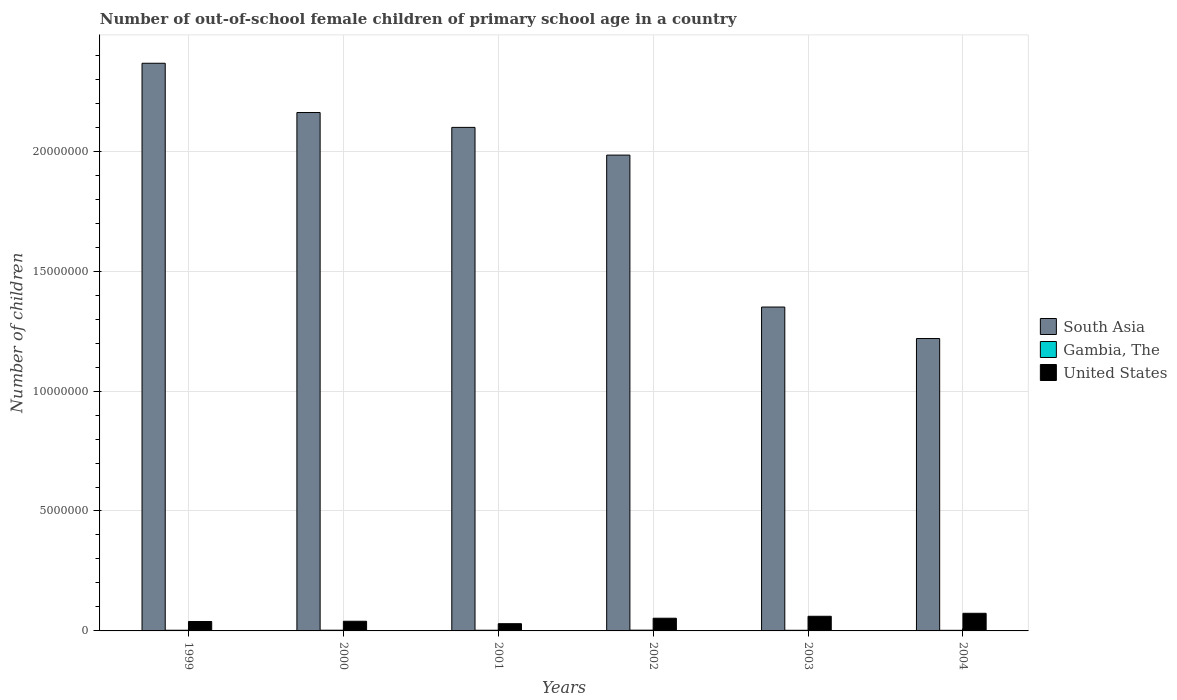How many groups of bars are there?
Make the answer very short. 6. Are the number of bars per tick equal to the number of legend labels?
Provide a succinct answer. Yes. Are the number of bars on each tick of the X-axis equal?
Your response must be concise. Yes. How many bars are there on the 6th tick from the left?
Your answer should be compact. 3. What is the label of the 5th group of bars from the left?
Your answer should be very brief. 2003. What is the number of out-of-school female children in South Asia in 2002?
Keep it short and to the point. 1.98e+07. Across all years, what is the maximum number of out-of-school female children in United States?
Your response must be concise. 7.35e+05. Across all years, what is the minimum number of out-of-school female children in United States?
Provide a short and direct response. 3.01e+05. In which year was the number of out-of-school female children in South Asia maximum?
Offer a very short reply. 1999. In which year was the number of out-of-school female children in United States minimum?
Make the answer very short. 2001. What is the total number of out-of-school female children in United States in the graph?
Make the answer very short. 2.97e+06. What is the difference between the number of out-of-school female children in Gambia, The in 2000 and that in 2004?
Provide a short and direct response. 4613. What is the difference between the number of out-of-school female children in South Asia in 2003 and the number of out-of-school female children in United States in 2001?
Your answer should be very brief. 1.32e+07. What is the average number of out-of-school female children in Gambia, The per year?
Offer a terse response. 2.82e+04. In the year 2003, what is the difference between the number of out-of-school female children in Gambia, The and number of out-of-school female children in South Asia?
Offer a very short reply. -1.35e+07. What is the ratio of the number of out-of-school female children in South Asia in 2001 to that in 2002?
Your answer should be compact. 1.06. Is the difference between the number of out-of-school female children in Gambia, The in 2001 and 2004 greater than the difference between the number of out-of-school female children in South Asia in 2001 and 2004?
Ensure brevity in your answer.  No. What is the difference between the highest and the second highest number of out-of-school female children in Gambia, The?
Your answer should be very brief. 1330. What is the difference between the highest and the lowest number of out-of-school female children in Gambia, The?
Provide a succinct answer. 5943. In how many years, is the number of out-of-school female children in United States greater than the average number of out-of-school female children in United States taken over all years?
Your answer should be very brief. 3. Is the sum of the number of out-of-school female children in South Asia in 2002 and 2004 greater than the maximum number of out-of-school female children in Gambia, The across all years?
Offer a terse response. Yes. What does the 2nd bar from the left in 2002 represents?
Keep it short and to the point. Gambia, The. What does the 2nd bar from the right in 2003 represents?
Provide a short and direct response. Gambia, The. Are all the bars in the graph horizontal?
Make the answer very short. No. How many years are there in the graph?
Ensure brevity in your answer.  6. Does the graph contain any zero values?
Provide a succinct answer. No. Does the graph contain grids?
Give a very brief answer. Yes. Where does the legend appear in the graph?
Your answer should be very brief. Center right. How are the legend labels stacked?
Provide a short and direct response. Vertical. What is the title of the graph?
Offer a very short reply. Number of out-of-school female children of primary school age in a country. What is the label or title of the X-axis?
Make the answer very short. Years. What is the label or title of the Y-axis?
Your answer should be very brief. Number of children. What is the Number of children in South Asia in 1999?
Provide a short and direct response. 2.37e+07. What is the Number of children of Gambia, The in 1999?
Give a very brief answer. 2.84e+04. What is the Number of children of United States in 1999?
Make the answer very short. 3.93e+05. What is the Number of children of South Asia in 2000?
Ensure brevity in your answer.  2.16e+07. What is the Number of children in Gambia, The in 2000?
Your response must be concise. 2.99e+04. What is the Number of children of United States in 2000?
Keep it short and to the point. 4.03e+05. What is the Number of children of South Asia in 2001?
Make the answer very short. 2.10e+07. What is the Number of children of Gambia, The in 2001?
Make the answer very short. 2.83e+04. What is the Number of children in United States in 2001?
Make the answer very short. 3.01e+05. What is the Number of children in South Asia in 2002?
Make the answer very short. 1.98e+07. What is the Number of children of Gambia, The in 2002?
Ensure brevity in your answer.  3.12e+04. What is the Number of children in United States in 2002?
Provide a succinct answer. 5.29e+05. What is the Number of children in South Asia in 2003?
Offer a very short reply. 1.35e+07. What is the Number of children in Gambia, The in 2003?
Offer a terse response. 2.61e+04. What is the Number of children of United States in 2003?
Offer a very short reply. 6.11e+05. What is the Number of children in South Asia in 2004?
Offer a very short reply. 1.22e+07. What is the Number of children in Gambia, The in 2004?
Offer a very short reply. 2.53e+04. What is the Number of children of United States in 2004?
Your response must be concise. 7.35e+05. Across all years, what is the maximum Number of children in South Asia?
Offer a terse response. 2.37e+07. Across all years, what is the maximum Number of children in Gambia, The?
Your answer should be very brief. 3.12e+04. Across all years, what is the maximum Number of children of United States?
Provide a short and direct response. 7.35e+05. Across all years, what is the minimum Number of children of South Asia?
Offer a terse response. 1.22e+07. Across all years, what is the minimum Number of children in Gambia, The?
Make the answer very short. 2.53e+04. Across all years, what is the minimum Number of children in United States?
Provide a succinct answer. 3.01e+05. What is the total Number of children of South Asia in the graph?
Give a very brief answer. 1.12e+08. What is the total Number of children in Gambia, The in the graph?
Offer a terse response. 1.69e+05. What is the total Number of children in United States in the graph?
Your answer should be compact. 2.97e+06. What is the difference between the Number of children in South Asia in 1999 and that in 2000?
Ensure brevity in your answer.  2.05e+06. What is the difference between the Number of children of Gambia, The in 1999 and that in 2000?
Provide a succinct answer. -1558. What is the difference between the Number of children of United States in 1999 and that in 2000?
Provide a succinct answer. -1.00e+04. What is the difference between the Number of children of South Asia in 1999 and that in 2001?
Your response must be concise. 2.67e+06. What is the difference between the Number of children in United States in 1999 and that in 2001?
Ensure brevity in your answer.  9.15e+04. What is the difference between the Number of children of South Asia in 1999 and that in 2002?
Ensure brevity in your answer.  3.83e+06. What is the difference between the Number of children in Gambia, The in 1999 and that in 2002?
Offer a terse response. -2888. What is the difference between the Number of children of United States in 1999 and that in 2002?
Give a very brief answer. -1.36e+05. What is the difference between the Number of children in South Asia in 1999 and that in 2003?
Your answer should be very brief. 1.02e+07. What is the difference between the Number of children of Gambia, The in 1999 and that in 2003?
Your answer should be very brief. 2246. What is the difference between the Number of children in United States in 1999 and that in 2003?
Your response must be concise. -2.18e+05. What is the difference between the Number of children in South Asia in 1999 and that in 2004?
Make the answer very short. 1.15e+07. What is the difference between the Number of children of Gambia, The in 1999 and that in 2004?
Give a very brief answer. 3055. What is the difference between the Number of children of United States in 1999 and that in 2004?
Your answer should be compact. -3.42e+05. What is the difference between the Number of children of South Asia in 2000 and that in 2001?
Keep it short and to the point. 6.19e+05. What is the difference between the Number of children in Gambia, The in 2000 and that in 2001?
Your answer should be compact. 1583. What is the difference between the Number of children in United States in 2000 and that in 2001?
Make the answer very short. 1.01e+05. What is the difference between the Number of children of South Asia in 2000 and that in 2002?
Ensure brevity in your answer.  1.78e+06. What is the difference between the Number of children in Gambia, The in 2000 and that in 2002?
Offer a terse response. -1330. What is the difference between the Number of children in United States in 2000 and that in 2002?
Provide a succinct answer. -1.26e+05. What is the difference between the Number of children of South Asia in 2000 and that in 2003?
Your answer should be compact. 8.11e+06. What is the difference between the Number of children of Gambia, The in 2000 and that in 2003?
Provide a succinct answer. 3804. What is the difference between the Number of children in United States in 2000 and that in 2003?
Provide a succinct answer. -2.08e+05. What is the difference between the Number of children in South Asia in 2000 and that in 2004?
Your response must be concise. 9.42e+06. What is the difference between the Number of children of Gambia, The in 2000 and that in 2004?
Offer a very short reply. 4613. What is the difference between the Number of children of United States in 2000 and that in 2004?
Offer a very short reply. -3.32e+05. What is the difference between the Number of children in South Asia in 2001 and that in 2002?
Your answer should be compact. 1.16e+06. What is the difference between the Number of children in Gambia, The in 2001 and that in 2002?
Provide a short and direct response. -2913. What is the difference between the Number of children of United States in 2001 and that in 2002?
Provide a short and direct response. -2.28e+05. What is the difference between the Number of children in South Asia in 2001 and that in 2003?
Your response must be concise. 7.49e+06. What is the difference between the Number of children of Gambia, The in 2001 and that in 2003?
Offer a very short reply. 2221. What is the difference between the Number of children of United States in 2001 and that in 2003?
Give a very brief answer. -3.09e+05. What is the difference between the Number of children in South Asia in 2001 and that in 2004?
Your answer should be very brief. 8.80e+06. What is the difference between the Number of children in Gambia, The in 2001 and that in 2004?
Your answer should be very brief. 3030. What is the difference between the Number of children in United States in 2001 and that in 2004?
Ensure brevity in your answer.  -4.34e+05. What is the difference between the Number of children of South Asia in 2002 and that in 2003?
Offer a very short reply. 6.33e+06. What is the difference between the Number of children of Gambia, The in 2002 and that in 2003?
Ensure brevity in your answer.  5134. What is the difference between the Number of children of United States in 2002 and that in 2003?
Give a very brief answer. -8.13e+04. What is the difference between the Number of children of South Asia in 2002 and that in 2004?
Ensure brevity in your answer.  7.65e+06. What is the difference between the Number of children of Gambia, The in 2002 and that in 2004?
Your response must be concise. 5943. What is the difference between the Number of children of United States in 2002 and that in 2004?
Your response must be concise. -2.06e+05. What is the difference between the Number of children in South Asia in 2003 and that in 2004?
Provide a succinct answer. 1.31e+06. What is the difference between the Number of children of Gambia, The in 2003 and that in 2004?
Offer a very short reply. 809. What is the difference between the Number of children in United States in 2003 and that in 2004?
Offer a very short reply. -1.24e+05. What is the difference between the Number of children of South Asia in 1999 and the Number of children of Gambia, The in 2000?
Offer a very short reply. 2.36e+07. What is the difference between the Number of children of South Asia in 1999 and the Number of children of United States in 2000?
Keep it short and to the point. 2.33e+07. What is the difference between the Number of children of Gambia, The in 1999 and the Number of children of United States in 2000?
Offer a terse response. -3.74e+05. What is the difference between the Number of children in South Asia in 1999 and the Number of children in Gambia, The in 2001?
Your response must be concise. 2.36e+07. What is the difference between the Number of children of South Asia in 1999 and the Number of children of United States in 2001?
Give a very brief answer. 2.34e+07. What is the difference between the Number of children in Gambia, The in 1999 and the Number of children in United States in 2001?
Make the answer very short. -2.73e+05. What is the difference between the Number of children of South Asia in 1999 and the Number of children of Gambia, The in 2002?
Give a very brief answer. 2.36e+07. What is the difference between the Number of children of South Asia in 1999 and the Number of children of United States in 2002?
Your answer should be compact. 2.31e+07. What is the difference between the Number of children in Gambia, The in 1999 and the Number of children in United States in 2002?
Offer a very short reply. -5.01e+05. What is the difference between the Number of children in South Asia in 1999 and the Number of children in Gambia, The in 2003?
Provide a short and direct response. 2.36e+07. What is the difference between the Number of children in South Asia in 1999 and the Number of children in United States in 2003?
Your answer should be compact. 2.31e+07. What is the difference between the Number of children in Gambia, The in 1999 and the Number of children in United States in 2003?
Offer a terse response. -5.82e+05. What is the difference between the Number of children of South Asia in 1999 and the Number of children of Gambia, The in 2004?
Your response must be concise. 2.36e+07. What is the difference between the Number of children in South Asia in 1999 and the Number of children in United States in 2004?
Offer a terse response. 2.29e+07. What is the difference between the Number of children of Gambia, The in 1999 and the Number of children of United States in 2004?
Make the answer very short. -7.07e+05. What is the difference between the Number of children of South Asia in 2000 and the Number of children of Gambia, The in 2001?
Give a very brief answer. 2.16e+07. What is the difference between the Number of children of South Asia in 2000 and the Number of children of United States in 2001?
Give a very brief answer. 2.13e+07. What is the difference between the Number of children of Gambia, The in 2000 and the Number of children of United States in 2001?
Your response must be concise. -2.71e+05. What is the difference between the Number of children in South Asia in 2000 and the Number of children in Gambia, The in 2002?
Provide a succinct answer. 2.16e+07. What is the difference between the Number of children of South Asia in 2000 and the Number of children of United States in 2002?
Offer a terse response. 2.11e+07. What is the difference between the Number of children in Gambia, The in 2000 and the Number of children in United States in 2002?
Provide a short and direct response. -4.99e+05. What is the difference between the Number of children in South Asia in 2000 and the Number of children in Gambia, The in 2003?
Give a very brief answer. 2.16e+07. What is the difference between the Number of children in South Asia in 2000 and the Number of children in United States in 2003?
Make the answer very short. 2.10e+07. What is the difference between the Number of children of Gambia, The in 2000 and the Number of children of United States in 2003?
Your response must be concise. -5.81e+05. What is the difference between the Number of children of South Asia in 2000 and the Number of children of Gambia, The in 2004?
Offer a terse response. 2.16e+07. What is the difference between the Number of children in South Asia in 2000 and the Number of children in United States in 2004?
Your answer should be very brief. 2.09e+07. What is the difference between the Number of children in Gambia, The in 2000 and the Number of children in United States in 2004?
Offer a very short reply. -7.05e+05. What is the difference between the Number of children in South Asia in 2001 and the Number of children in Gambia, The in 2002?
Offer a terse response. 2.10e+07. What is the difference between the Number of children in South Asia in 2001 and the Number of children in United States in 2002?
Provide a succinct answer. 2.05e+07. What is the difference between the Number of children in Gambia, The in 2001 and the Number of children in United States in 2002?
Keep it short and to the point. -5.01e+05. What is the difference between the Number of children of South Asia in 2001 and the Number of children of Gambia, The in 2003?
Ensure brevity in your answer.  2.10e+07. What is the difference between the Number of children in South Asia in 2001 and the Number of children in United States in 2003?
Make the answer very short. 2.04e+07. What is the difference between the Number of children of Gambia, The in 2001 and the Number of children of United States in 2003?
Your answer should be very brief. -5.82e+05. What is the difference between the Number of children in South Asia in 2001 and the Number of children in Gambia, The in 2004?
Offer a terse response. 2.10e+07. What is the difference between the Number of children in South Asia in 2001 and the Number of children in United States in 2004?
Offer a terse response. 2.03e+07. What is the difference between the Number of children in Gambia, The in 2001 and the Number of children in United States in 2004?
Your answer should be compact. -7.07e+05. What is the difference between the Number of children of South Asia in 2002 and the Number of children of Gambia, The in 2003?
Give a very brief answer. 1.98e+07. What is the difference between the Number of children of South Asia in 2002 and the Number of children of United States in 2003?
Offer a very short reply. 1.92e+07. What is the difference between the Number of children in Gambia, The in 2002 and the Number of children in United States in 2003?
Ensure brevity in your answer.  -5.79e+05. What is the difference between the Number of children in South Asia in 2002 and the Number of children in Gambia, The in 2004?
Offer a very short reply. 1.98e+07. What is the difference between the Number of children of South Asia in 2002 and the Number of children of United States in 2004?
Give a very brief answer. 1.91e+07. What is the difference between the Number of children in Gambia, The in 2002 and the Number of children in United States in 2004?
Offer a terse response. -7.04e+05. What is the difference between the Number of children of South Asia in 2003 and the Number of children of Gambia, The in 2004?
Give a very brief answer. 1.35e+07. What is the difference between the Number of children in South Asia in 2003 and the Number of children in United States in 2004?
Your answer should be compact. 1.28e+07. What is the difference between the Number of children of Gambia, The in 2003 and the Number of children of United States in 2004?
Give a very brief answer. -7.09e+05. What is the average Number of children in South Asia per year?
Make the answer very short. 1.86e+07. What is the average Number of children in Gambia, The per year?
Give a very brief answer. 2.82e+04. What is the average Number of children of United States per year?
Your response must be concise. 4.95e+05. In the year 1999, what is the difference between the Number of children in South Asia and Number of children in Gambia, The?
Provide a short and direct response. 2.36e+07. In the year 1999, what is the difference between the Number of children in South Asia and Number of children in United States?
Ensure brevity in your answer.  2.33e+07. In the year 1999, what is the difference between the Number of children of Gambia, The and Number of children of United States?
Make the answer very short. -3.64e+05. In the year 2000, what is the difference between the Number of children of South Asia and Number of children of Gambia, The?
Your answer should be very brief. 2.16e+07. In the year 2000, what is the difference between the Number of children in South Asia and Number of children in United States?
Your answer should be very brief. 2.12e+07. In the year 2000, what is the difference between the Number of children in Gambia, The and Number of children in United States?
Offer a terse response. -3.73e+05. In the year 2001, what is the difference between the Number of children of South Asia and Number of children of Gambia, The?
Make the answer very short. 2.10e+07. In the year 2001, what is the difference between the Number of children of South Asia and Number of children of United States?
Make the answer very short. 2.07e+07. In the year 2001, what is the difference between the Number of children in Gambia, The and Number of children in United States?
Ensure brevity in your answer.  -2.73e+05. In the year 2002, what is the difference between the Number of children in South Asia and Number of children in Gambia, The?
Keep it short and to the point. 1.98e+07. In the year 2002, what is the difference between the Number of children of South Asia and Number of children of United States?
Offer a very short reply. 1.93e+07. In the year 2002, what is the difference between the Number of children in Gambia, The and Number of children in United States?
Give a very brief answer. -4.98e+05. In the year 2003, what is the difference between the Number of children in South Asia and Number of children in Gambia, The?
Make the answer very short. 1.35e+07. In the year 2003, what is the difference between the Number of children in South Asia and Number of children in United States?
Make the answer very short. 1.29e+07. In the year 2003, what is the difference between the Number of children in Gambia, The and Number of children in United States?
Your answer should be compact. -5.85e+05. In the year 2004, what is the difference between the Number of children of South Asia and Number of children of Gambia, The?
Provide a short and direct response. 1.22e+07. In the year 2004, what is the difference between the Number of children of South Asia and Number of children of United States?
Give a very brief answer. 1.15e+07. In the year 2004, what is the difference between the Number of children of Gambia, The and Number of children of United States?
Ensure brevity in your answer.  -7.10e+05. What is the ratio of the Number of children in South Asia in 1999 to that in 2000?
Offer a very short reply. 1.09. What is the ratio of the Number of children in Gambia, The in 1999 to that in 2000?
Keep it short and to the point. 0.95. What is the ratio of the Number of children of United States in 1999 to that in 2000?
Ensure brevity in your answer.  0.98. What is the ratio of the Number of children of South Asia in 1999 to that in 2001?
Offer a terse response. 1.13. What is the ratio of the Number of children of United States in 1999 to that in 2001?
Ensure brevity in your answer.  1.3. What is the ratio of the Number of children of South Asia in 1999 to that in 2002?
Offer a terse response. 1.19. What is the ratio of the Number of children of Gambia, The in 1999 to that in 2002?
Provide a succinct answer. 0.91. What is the ratio of the Number of children of United States in 1999 to that in 2002?
Provide a short and direct response. 0.74. What is the ratio of the Number of children of South Asia in 1999 to that in 2003?
Ensure brevity in your answer.  1.75. What is the ratio of the Number of children of Gambia, The in 1999 to that in 2003?
Your answer should be very brief. 1.09. What is the ratio of the Number of children in United States in 1999 to that in 2003?
Provide a succinct answer. 0.64. What is the ratio of the Number of children of South Asia in 1999 to that in 2004?
Offer a terse response. 1.94. What is the ratio of the Number of children in Gambia, The in 1999 to that in 2004?
Offer a terse response. 1.12. What is the ratio of the Number of children in United States in 1999 to that in 2004?
Your response must be concise. 0.53. What is the ratio of the Number of children of South Asia in 2000 to that in 2001?
Give a very brief answer. 1.03. What is the ratio of the Number of children of Gambia, The in 2000 to that in 2001?
Give a very brief answer. 1.06. What is the ratio of the Number of children in United States in 2000 to that in 2001?
Give a very brief answer. 1.34. What is the ratio of the Number of children of South Asia in 2000 to that in 2002?
Ensure brevity in your answer.  1.09. What is the ratio of the Number of children in Gambia, The in 2000 to that in 2002?
Offer a very short reply. 0.96. What is the ratio of the Number of children of United States in 2000 to that in 2002?
Ensure brevity in your answer.  0.76. What is the ratio of the Number of children of South Asia in 2000 to that in 2003?
Your answer should be very brief. 1.6. What is the ratio of the Number of children of Gambia, The in 2000 to that in 2003?
Keep it short and to the point. 1.15. What is the ratio of the Number of children in United States in 2000 to that in 2003?
Ensure brevity in your answer.  0.66. What is the ratio of the Number of children of South Asia in 2000 to that in 2004?
Your answer should be very brief. 1.77. What is the ratio of the Number of children of Gambia, The in 2000 to that in 2004?
Your answer should be very brief. 1.18. What is the ratio of the Number of children of United States in 2000 to that in 2004?
Provide a short and direct response. 0.55. What is the ratio of the Number of children in South Asia in 2001 to that in 2002?
Keep it short and to the point. 1.06. What is the ratio of the Number of children in Gambia, The in 2001 to that in 2002?
Ensure brevity in your answer.  0.91. What is the ratio of the Number of children of United States in 2001 to that in 2002?
Keep it short and to the point. 0.57. What is the ratio of the Number of children of South Asia in 2001 to that in 2003?
Give a very brief answer. 1.55. What is the ratio of the Number of children of Gambia, The in 2001 to that in 2003?
Provide a short and direct response. 1.08. What is the ratio of the Number of children in United States in 2001 to that in 2003?
Make the answer very short. 0.49. What is the ratio of the Number of children in South Asia in 2001 to that in 2004?
Offer a terse response. 1.72. What is the ratio of the Number of children in Gambia, The in 2001 to that in 2004?
Keep it short and to the point. 1.12. What is the ratio of the Number of children of United States in 2001 to that in 2004?
Provide a short and direct response. 0.41. What is the ratio of the Number of children in South Asia in 2002 to that in 2003?
Offer a terse response. 1.47. What is the ratio of the Number of children in Gambia, The in 2002 to that in 2003?
Give a very brief answer. 1.2. What is the ratio of the Number of children of United States in 2002 to that in 2003?
Offer a terse response. 0.87. What is the ratio of the Number of children of South Asia in 2002 to that in 2004?
Provide a succinct answer. 1.63. What is the ratio of the Number of children in Gambia, The in 2002 to that in 2004?
Keep it short and to the point. 1.23. What is the ratio of the Number of children of United States in 2002 to that in 2004?
Keep it short and to the point. 0.72. What is the ratio of the Number of children in South Asia in 2003 to that in 2004?
Make the answer very short. 1.11. What is the ratio of the Number of children of Gambia, The in 2003 to that in 2004?
Ensure brevity in your answer.  1.03. What is the ratio of the Number of children of United States in 2003 to that in 2004?
Your answer should be very brief. 0.83. What is the difference between the highest and the second highest Number of children in South Asia?
Offer a terse response. 2.05e+06. What is the difference between the highest and the second highest Number of children in Gambia, The?
Provide a short and direct response. 1330. What is the difference between the highest and the second highest Number of children in United States?
Your answer should be compact. 1.24e+05. What is the difference between the highest and the lowest Number of children of South Asia?
Provide a short and direct response. 1.15e+07. What is the difference between the highest and the lowest Number of children in Gambia, The?
Provide a short and direct response. 5943. What is the difference between the highest and the lowest Number of children of United States?
Offer a terse response. 4.34e+05. 